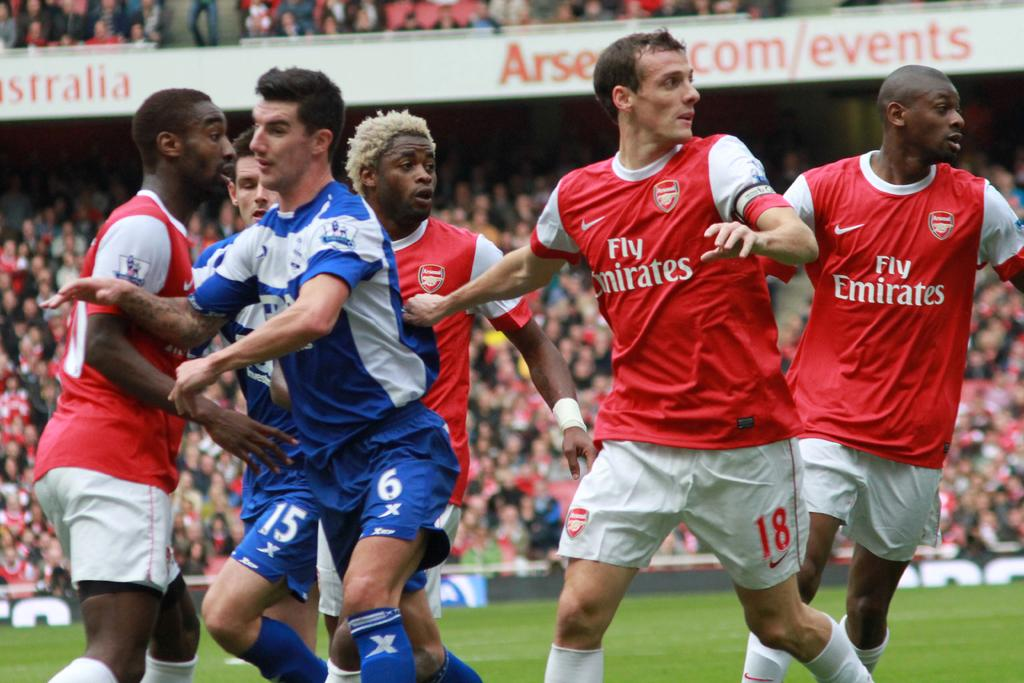<image>
Create a compact narrative representing the image presented. Group of players playing soccer including a team for Fly Emirates. 